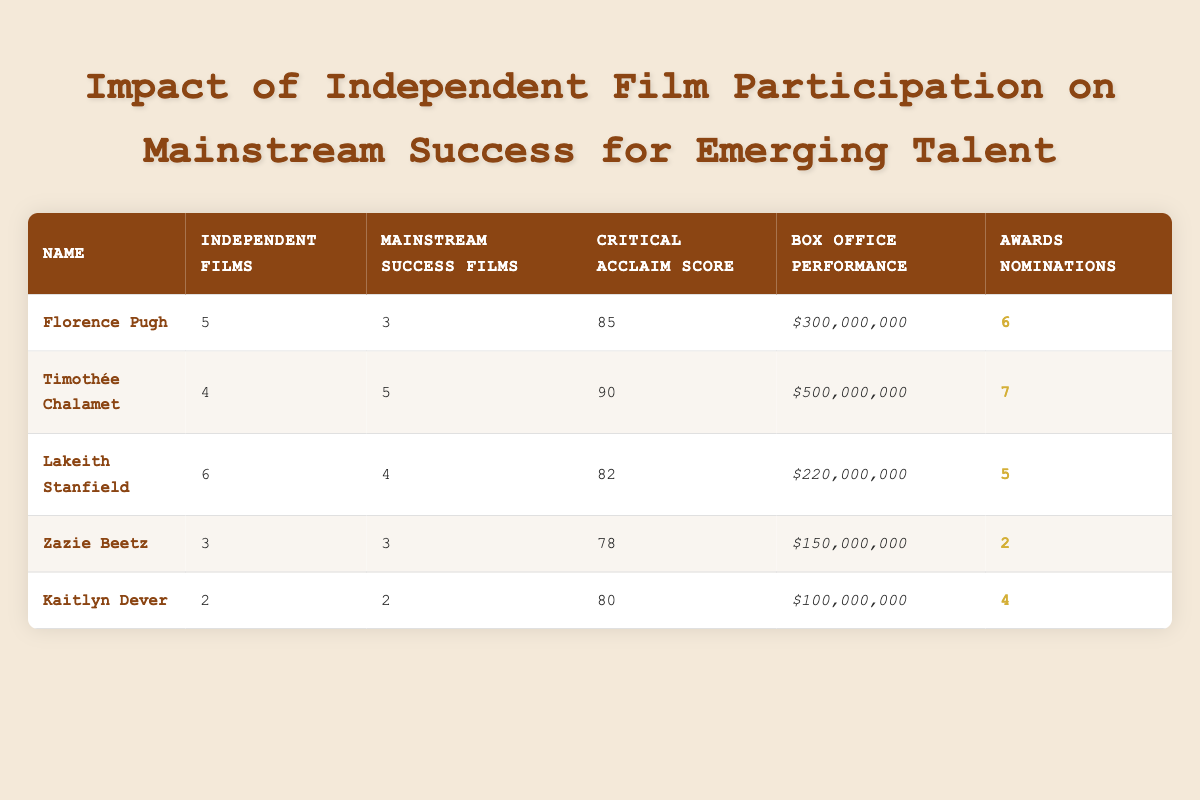What is the critical acclaim score of Timothée Chalamet? The table lists Timothée Chalamet's critical acclaim score directly in the corresponding row, which shows a score of 90.
Answer: 90 How many awards nominations did Florence Pugh receive? Looking at the table, Florence Pugh's row indicates she received 6 awards nominations.
Answer: 6 Is Lakeith Stanfield's box office performance greater than 250 million dollars? Lakeith Stanfield's box office performance is listed as 220 million dollars in the table, which is less than 250 million, making the statement false.
Answer: No What is the total number of independent films participated in by all listed talents? To find the total, we sum the independent films: 5 (Pugh) + 4 (Chalamet) + 6 (Stanfield) + 3 (Beetz) + 2 (Dever) = 20 independent films in total.
Answer: 20 Which actor has both the highest critical acclaim score and the most mainstream success films? By examining the table, Timothée Chalamet has the highest critical acclaim score of 90 and also has 5 mainstream success films, which is more than any other actor on the list.
Answer: Timothée Chalamet How does the average box office performance of actors with 4 or more independent films compare to those with fewer? For actors with 4 or more independent films (Chalamet and Stanfield), their box office performance adds up to 500 million + 220 million = 720 million, averaging 720 million / 2 = 360 million. For those with fewer independent films (Pugh, Beetz, and Dever), the total is 300 million + 150 million + 100 million = 550 million, averaging 550 million / 3 = approximately 183.33 million. Thus, the average for actors with 4 or more films (360 million) is higher than for those with fewer (approximately 183.33 million).
Answer: Yes, higher Does Zazie Beetz have more independent films than Kaitlyn Dever? In the table, Zazie Beetz has 3 independent films while Kaitlyn Dever has 2, making the answer yes.
Answer: Yes 